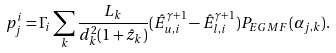Convert formula to latex. <formula><loc_0><loc_0><loc_500><loc_500>p _ { j } ^ { i } = \Gamma _ { i } \sum _ { k } \frac { L _ { k } } { d _ { k } ^ { 2 } ( 1 + \hat { z } _ { k } ) } ( \hat { E } _ { u , i } ^ { \gamma + 1 } - \hat { E } _ { l , i } ^ { \gamma + 1 } ) P _ { E G M F } ( \alpha _ { j , k } ) .</formula> 